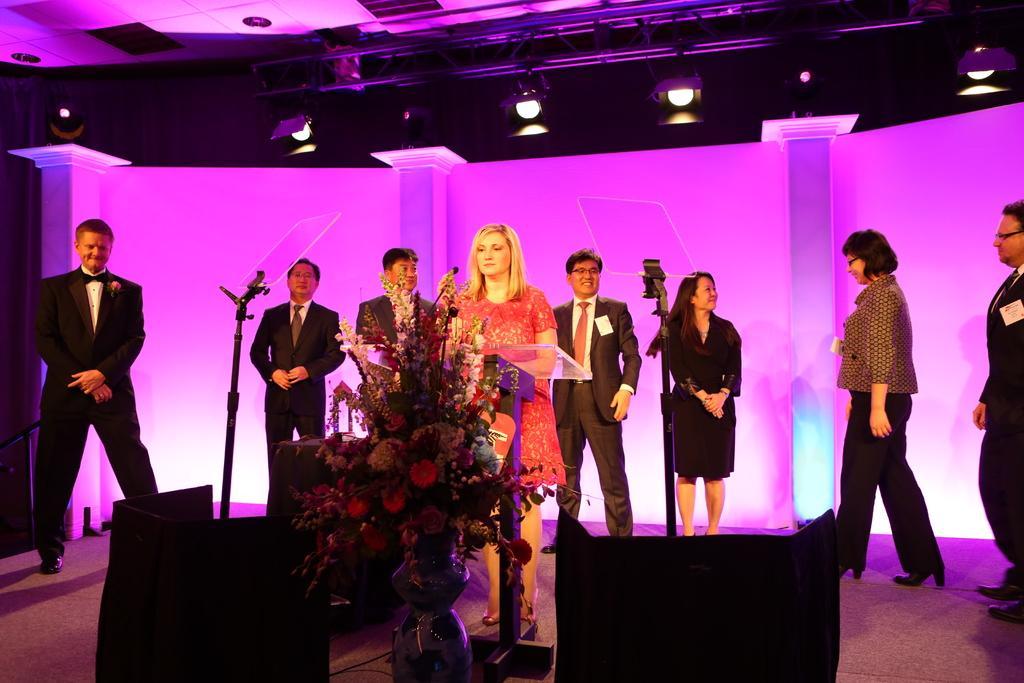Please provide a concise description of this image. In the foreground of this image, there is a flower vase and it seems like speakers on the bottom. In the middle, there is a woman standing near a podium holding a mic and we can also see few persons standing on the stage and also glass to the stands. In the background, there is the wall and the pink light. On the top, there are lights. 